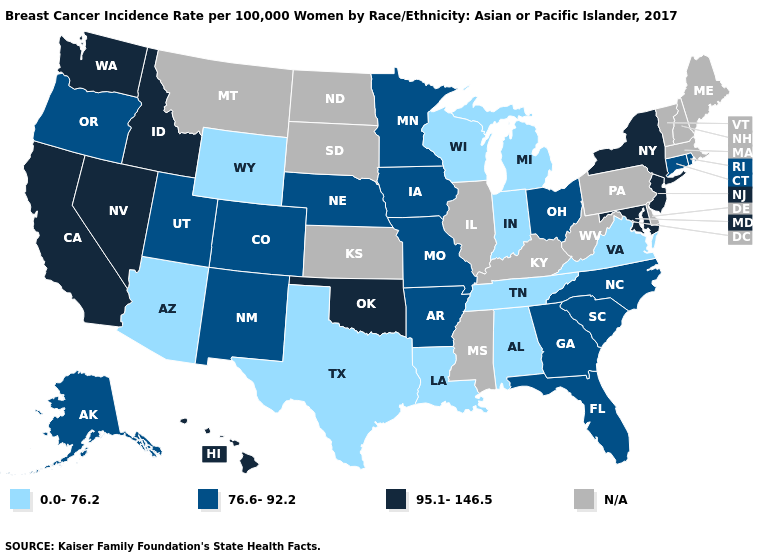Does Nebraska have the lowest value in the USA?
Quick response, please. No. Does the map have missing data?
Give a very brief answer. Yes. Among the states that border Washington , which have the lowest value?
Be succinct. Oregon. What is the value of North Carolina?
Short answer required. 76.6-92.2. What is the value of Oregon?
Answer briefly. 76.6-92.2. Which states have the lowest value in the USA?
Answer briefly. Alabama, Arizona, Indiana, Louisiana, Michigan, Tennessee, Texas, Virginia, Wisconsin, Wyoming. What is the value of Mississippi?
Short answer required. N/A. Which states have the lowest value in the USA?
Give a very brief answer. Alabama, Arizona, Indiana, Louisiana, Michigan, Tennessee, Texas, Virginia, Wisconsin, Wyoming. Does the map have missing data?
Concise answer only. Yes. What is the value of Oklahoma?
Give a very brief answer. 95.1-146.5. What is the value of Oregon?
Quick response, please. 76.6-92.2. What is the lowest value in states that border Georgia?
Answer briefly. 0.0-76.2. Name the states that have a value in the range N/A?
Concise answer only. Delaware, Illinois, Kansas, Kentucky, Maine, Massachusetts, Mississippi, Montana, New Hampshire, North Dakota, Pennsylvania, South Dakota, Vermont, West Virginia. What is the value of Kentucky?
Quick response, please. N/A. Name the states that have a value in the range 95.1-146.5?
Answer briefly. California, Hawaii, Idaho, Maryland, Nevada, New Jersey, New York, Oklahoma, Washington. 